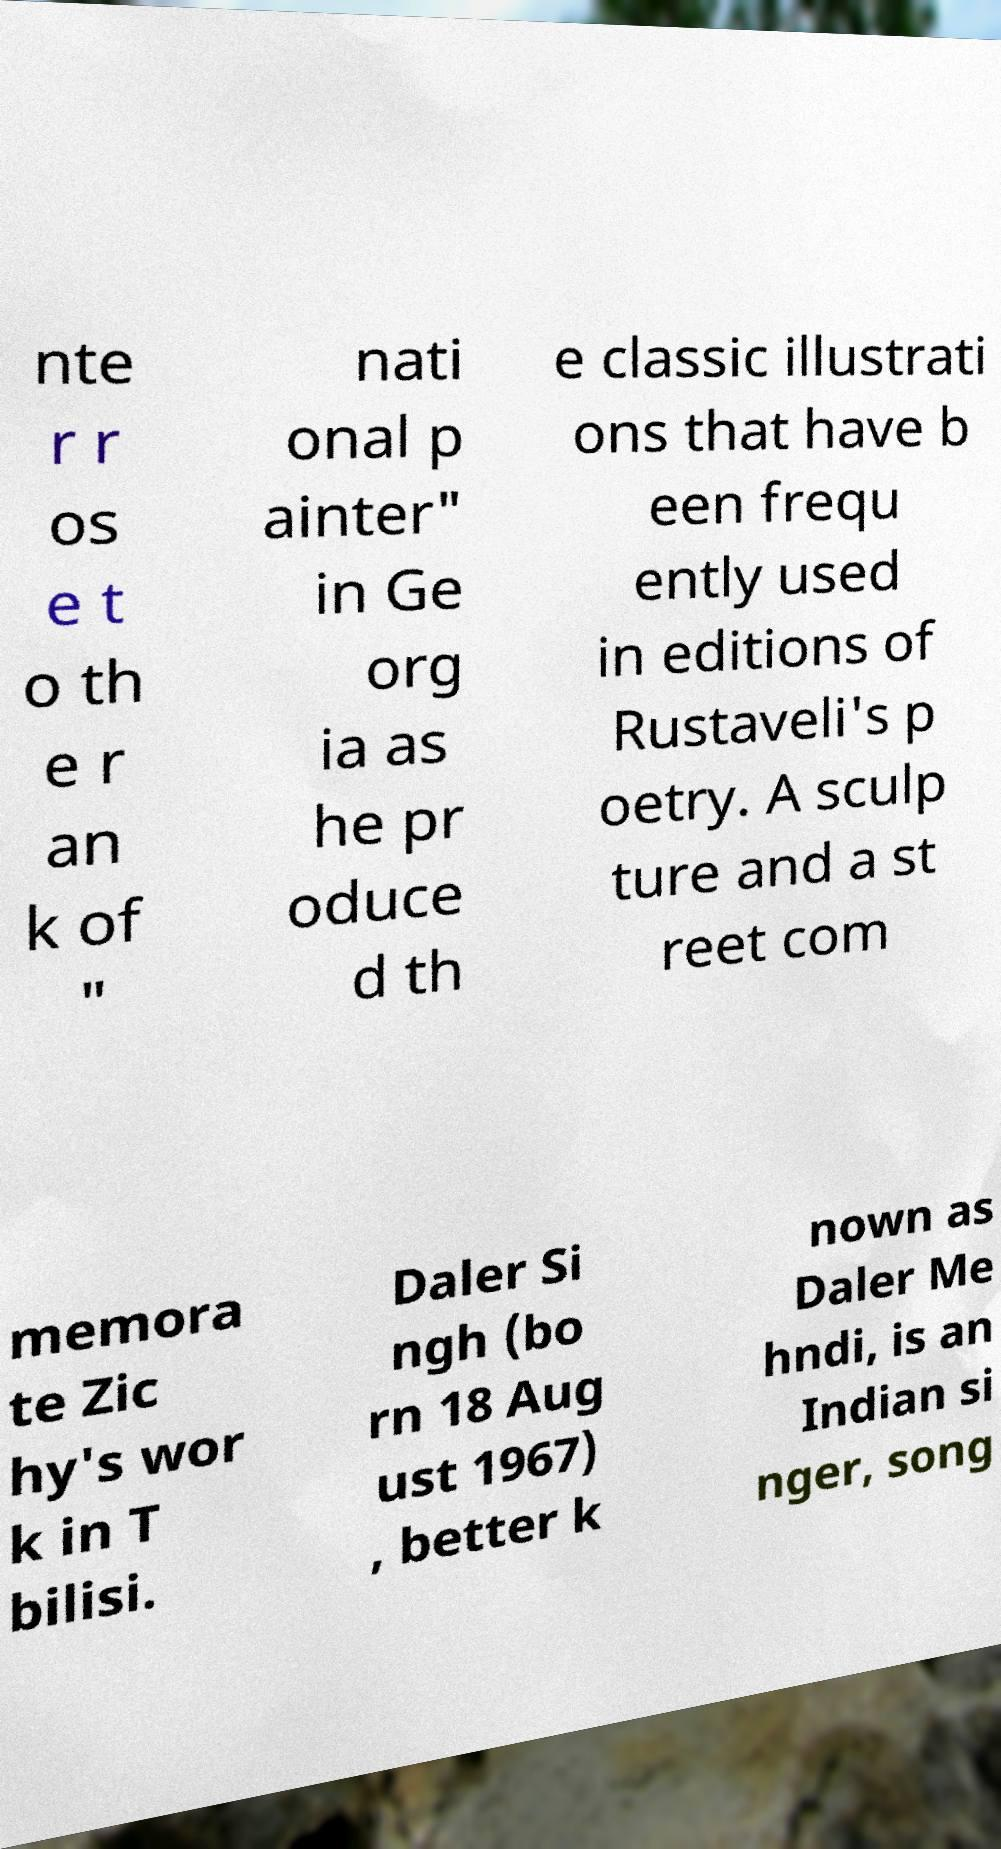What messages or text are displayed in this image? I need them in a readable, typed format. nte r r os e t o th e r an k of " nati onal p ainter" in Ge org ia as he pr oduce d th e classic illustrati ons that have b een frequ ently used in editions of Rustaveli's p oetry. A sculp ture and a st reet com memora te Zic hy's wor k in T bilisi. Daler Si ngh (bo rn 18 Aug ust 1967) , better k nown as Daler Me hndi, is an Indian si nger, song 